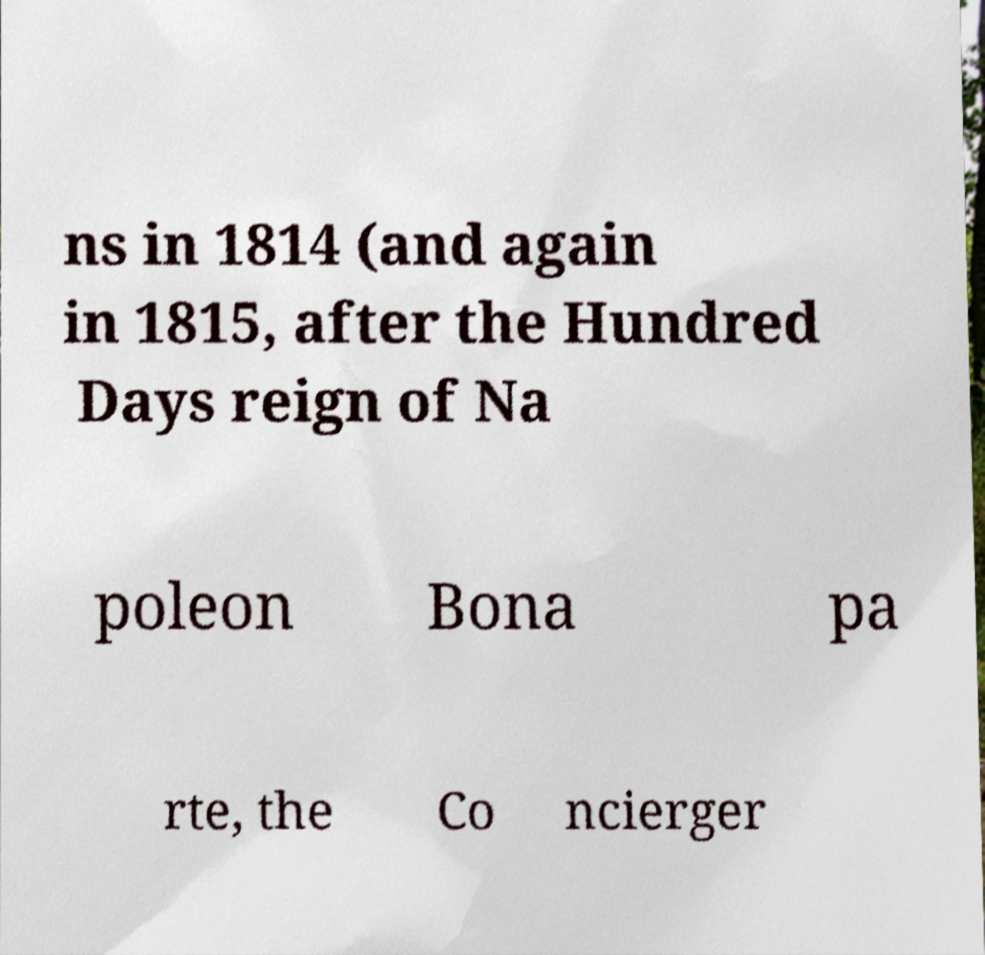Please identify and transcribe the text found in this image. ns in 1814 (and again in 1815, after the Hundred Days reign of Na poleon Bona pa rte, the Co ncierger 